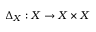Convert formula to latex. <formula><loc_0><loc_0><loc_500><loc_500>\Delta _ { X } \colon X \to X \times X</formula> 